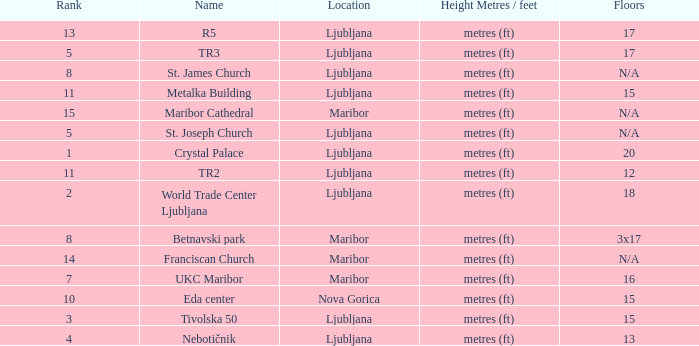Which Height Metres / feet has a Rank of 8, and Floors of 3x17? Metres (ft). 